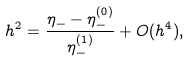<formula> <loc_0><loc_0><loc_500><loc_500>h ^ { 2 } = \frac { \eta _ { - } - \eta _ { - } ^ { ( 0 ) } } { \eta _ { - } ^ { ( 1 ) } } + O ( h ^ { 4 } ) ,</formula> 